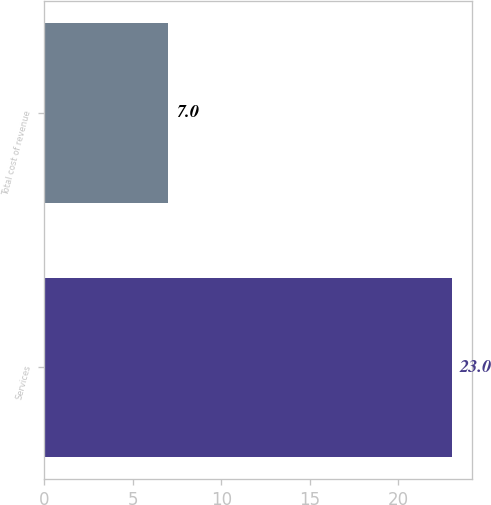<chart> <loc_0><loc_0><loc_500><loc_500><bar_chart><fcel>Services<fcel>Total cost of revenue<nl><fcel>23<fcel>7<nl></chart> 